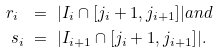<formula> <loc_0><loc_0><loc_500><loc_500>r _ { i } \ & = \ | I _ { i } \cap [ j _ { i } + 1 , j _ { i + 1 } ] | a n d \\ s _ { i } \ & = \ | I _ { i + 1 } \cap [ j _ { i } + 1 , j _ { i + 1 } ] | .</formula> 